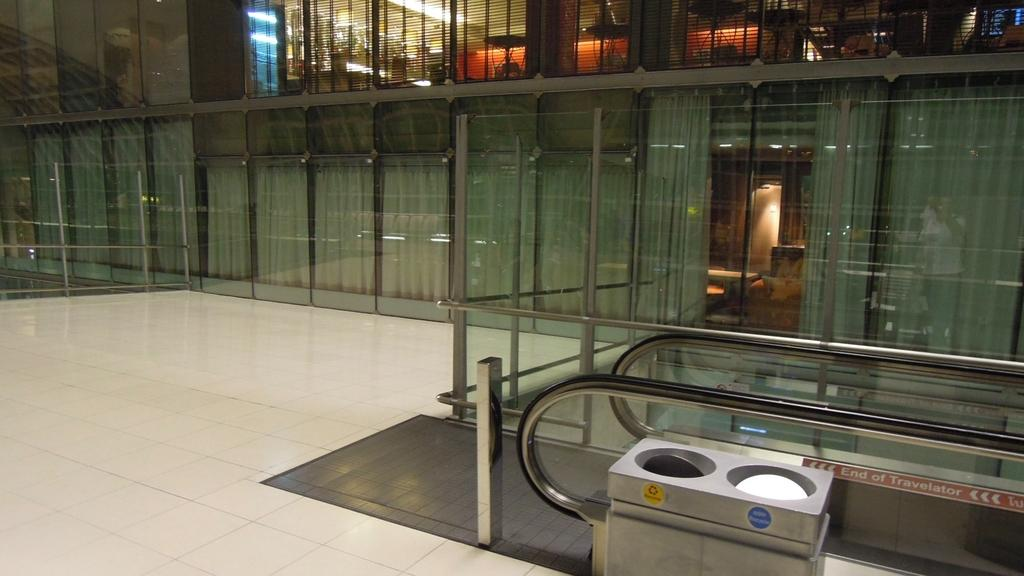<image>
Offer a succinct explanation of the picture presented. an empty mall floor with an escalator near sign reading End of Travelator 